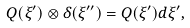<formula> <loc_0><loc_0><loc_500><loc_500>Q ( \xi ^ { \prime } ) \otimes \delta ( \xi ^ { \prime \prime } ) = Q ( \xi ^ { \prime } ) d \xi ^ { \prime } ,</formula> 